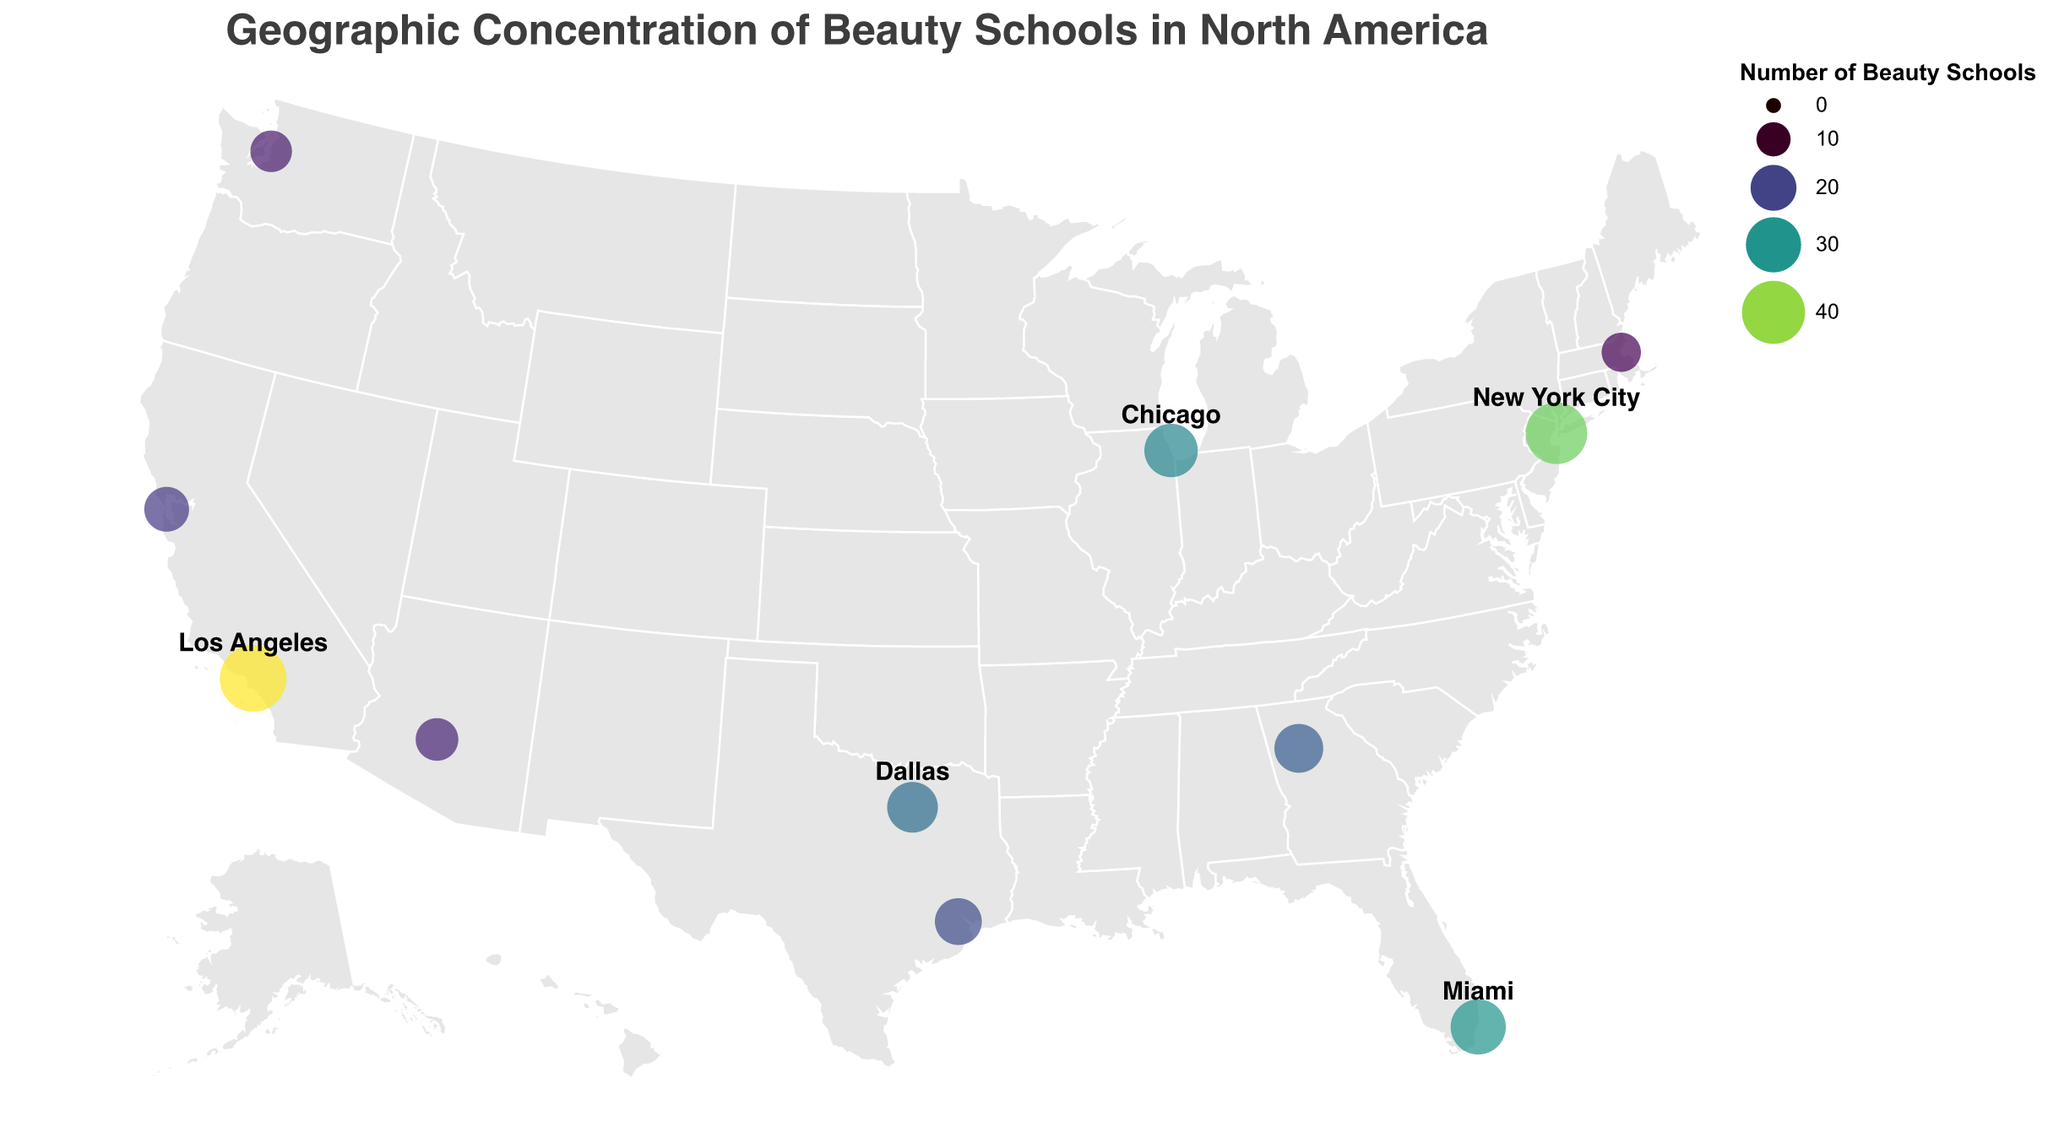Which city has the highest number of beauty schools? Look at the size and color of the circles on the given geographic plot. The larger and darker the circle, the higher the number of beauty schools. Los Angeles has the largest and darkest circle.
Answer: Los Angeles How many cities have more than 20 beauty schools? Count the cities whose circles are larger and darker, indicating more than 20 beauty schools. These cities are Los Angeles, New York City, Miami, Chicago, Dallas, and Atlanta.
Answer: 6 What is the total number of beauty schools in California? Sum the numbers of beauty schools in Los Angeles (45) and San Francisco (19), as both cities are in California. So, 45 + 19 = 64.
Answer: 64 Between New York City and Miami, which city has more beauty schools and by how much? Compare the circles for New York City and Miami. New York City has 38 beauty schools while Miami has 30. Subtract 30 from 38 to find the difference: 38 - 30 = 8. New York City has 8 more beauty schools.
Answer: New York City by 8 Which city is tied with another city in the number of beauty schools? Look for circles of the same size and color. Dallas and Houston are closest in both size and color but are not exactly the same; the closest match would be the visual inspection.
Answer: No exact tie, Dallas and Houston are closest What is the average number of beauty schools in the cities shown on the US map? Sum the numbers of beauty schools in all the cities and divide by the number of cities. Adding the numbers: 45 + 38 + 30 + 28 + 25 + 23 + 21 + 19 + 17 + 16 + 14. Sum = 276. Number of cities = 11. Average = 276 / 11 = 25.09 (approx).
Answer: Approximately 25 Which notable academy is located in Los Angeles, and how many beauty schools does it have? Check the tooltip or the provided data for Los Angeles. It mentions Paul Mitchell The School and the number of beauty schools is 45.
Answer: Paul Mitchell The School with 45 beauty schools How many notable academies are represented on the map, and what are their names? Each city has a notable academy listed in the tooltip. Count the different names: Paul Mitchell The School, Aveda Institute, Beauty Schools of America, Pivot Point Academy, Ogle School, Empire Beauty School, Franklin Beauty School, Cinta Aveda Institute, Avalon School of Cosmetology, Gene Juarez Academy, Elizabeth Grady School of Esthetics. Total = 11 names.
Answer: 11: Paul Mitchell The School, Aveda Institute, Beauty Schools of America, Pivot Point Academy, Ogle School, Empire Beauty School, Franklin Beauty School, Cinta Aveda Institute, Avalon School of Cosmetology, Gene Juarez Academy, Elizabeth Grady School of Esthetics 